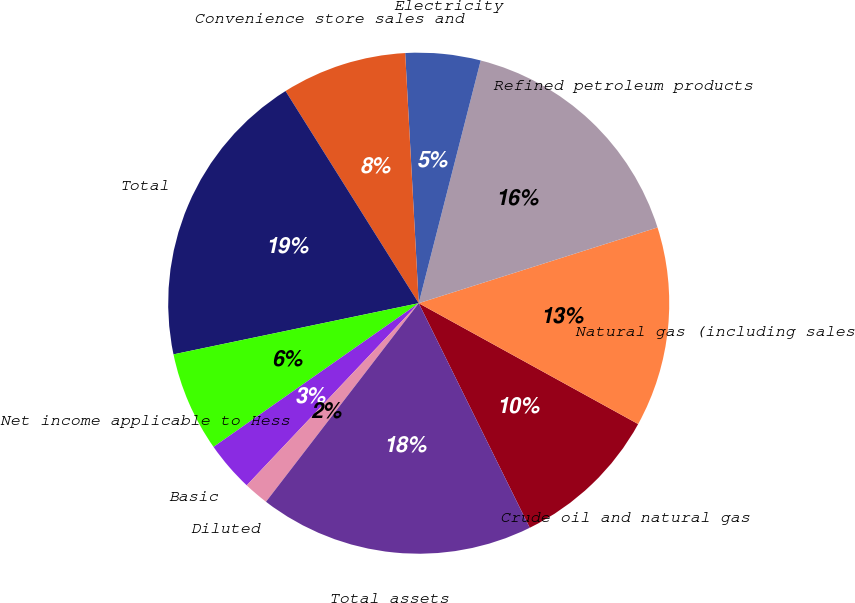Convert chart. <chart><loc_0><loc_0><loc_500><loc_500><pie_chart><fcel>Crude oil and natural gas<fcel>Natural gas (including sales<fcel>Refined petroleum products<fcel>Electricity<fcel>Convenience store sales and<fcel>Total<fcel>Net income applicable to Hess<fcel>Basic<fcel>Diluted<fcel>Total assets<nl><fcel>9.68%<fcel>12.9%<fcel>16.13%<fcel>4.84%<fcel>8.06%<fcel>19.35%<fcel>6.45%<fcel>3.23%<fcel>1.61%<fcel>17.74%<nl></chart> 